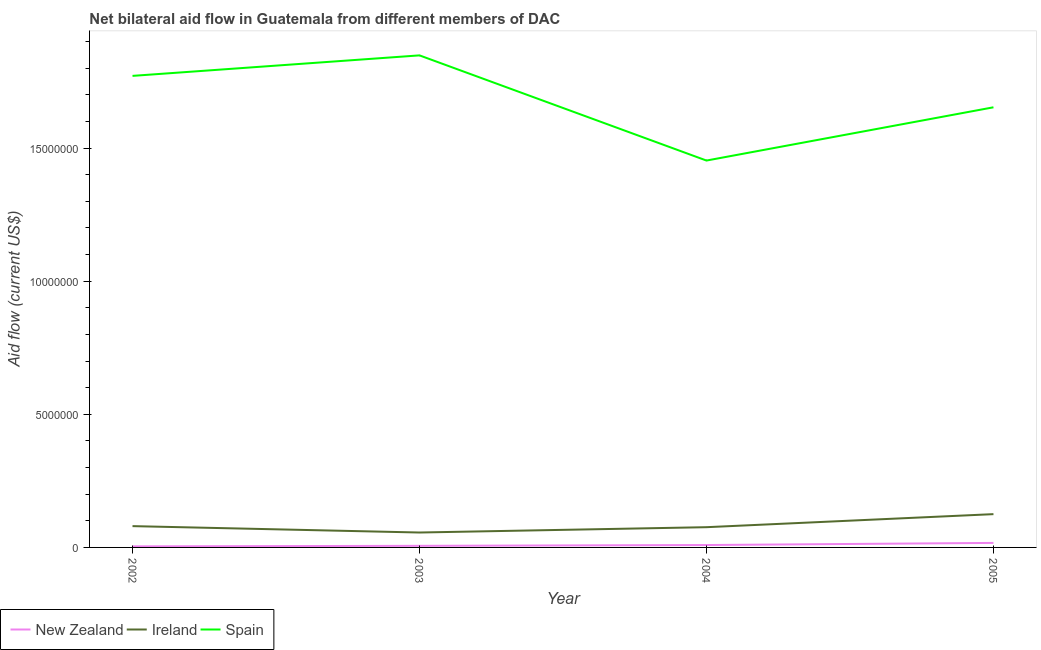What is the amount of aid provided by ireland in 2003?
Your answer should be very brief. 5.60e+05. Across all years, what is the maximum amount of aid provided by spain?
Provide a succinct answer. 1.85e+07. Across all years, what is the minimum amount of aid provided by spain?
Provide a short and direct response. 1.45e+07. In which year was the amount of aid provided by ireland minimum?
Keep it short and to the point. 2003. What is the total amount of aid provided by new zealand in the graph?
Ensure brevity in your answer.  3.60e+05. What is the difference between the amount of aid provided by ireland in 2003 and that in 2005?
Your answer should be compact. -6.90e+05. What is the difference between the amount of aid provided by spain in 2004 and the amount of aid provided by ireland in 2005?
Offer a terse response. 1.33e+07. What is the average amount of aid provided by spain per year?
Offer a very short reply. 1.68e+07. In the year 2005, what is the difference between the amount of aid provided by ireland and amount of aid provided by new zealand?
Ensure brevity in your answer.  1.08e+06. What is the ratio of the amount of aid provided by new zealand in 2003 to that in 2004?
Your answer should be very brief. 0.67. Is the amount of aid provided by ireland in 2003 less than that in 2004?
Ensure brevity in your answer.  Yes. What is the difference between the highest and the second highest amount of aid provided by spain?
Provide a short and direct response. 7.70e+05. What is the difference between the highest and the lowest amount of aid provided by spain?
Your answer should be compact. 3.95e+06. In how many years, is the amount of aid provided by new zealand greater than the average amount of aid provided by new zealand taken over all years?
Offer a terse response. 1. Is it the case that in every year, the sum of the amount of aid provided by new zealand and amount of aid provided by ireland is greater than the amount of aid provided by spain?
Provide a short and direct response. No. Is the amount of aid provided by spain strictly less than the amount of aid provided by ireland over the years?
Provide a short and direct response. No. How many lines are there?
Your response must be concise. 3. What is the difference between two consecutive major ticks on the Y-axis?
Offer a very short reply. 5.00e+06. Does the graph contain any zero values?
Make the answer very short. No. Does the graph contain grids?
Make the answer very short. No. Where does the legend appear in the graph?
Provide a succinct answer. Bottom left. How many legend labels are there?
Ensure brevity in your answer.  3. What is the title of the graph?
Make the answer very short. Net bilateral aid flow in Guatemala from different members of DAC. What is the label or title of the X-axis?
Your answer should be compact. Year. What is the Aid flow (current US$) in New Zealand in 2002?
Your response must be concise. 4.00e+04. What is the Aid flow (current US$) of Ireland in 2002?
Ensure brevity in your answer.  8.00e+05. What is the Aid flow (current US$) of Spain in 2002?
Your response must be concise. 1.77e+07. What is the Aid flow (current US$) in New Zealand in 2003?
Provide a short and direct response. 6.00e+04. What is the Aid flow (current US$) in Ireland in 2003?
Your answer should be very brief. 5.60e+05. What is the Aid flow (current US$) of Spain in 2003?
Your response must be concise. 1.85e+07. What is the Aid flow (current US$) of New Zealand in 2004?
Give a very brief answer. 9.00e+04. What is the Aid flow (current US$) of Ireland in 2004?
Make the answer very short. 7.60e+05. What is the Aid flow (current US$) of Spain in 2004?
Provide a short and direct response. 1.45e+07. What is the Aid flow (current US$) of Ireland in 2005?
Offer a terse response. 1.25e+06. What is the Aid flow (current US$) in Spain in 2005?
Offer a terse response. 1.65e+07. Across all years, what is the maximum Aid flow (current US$) in Ireland?
Your answer should be compact. 1.25e+06. Across all years, what is the maximum Aid flow (current US$) in Spain?
Your answer should be very brief. 1.85e+07. Across all years, what is the minimum Aid flow (current US$) in Ireland?
Make the answer very short. 5.60e+05. Across all years, what is the minimum Aid flow (current US$) in Spain?
Make the answer very short. 1.45e+07. What is the total Aid flow (current US$) in New Zealand in the graph?
Provide a succinct answer. 3.60e+05. What is the total Aid flow (current US$) in Ireland in the graph?
Provide a succinct answer. 3.37e+06. What is the total Aid flow (current US$) of Spain in the graph?
Give a very brief answer. 6.72e+07. What is the difference between the Aid flow (current US$) of New Zealand in 2002 and that in 2003?
Keep it short and to the point. -2.00e+04. What is the difference between the Aid flow (current US$) of Spain in 2002 and that in 2003?
Provide a succinct answer. -7.70e+05. What is the difference between the Aid flow (current US$) in Ireland in 2002 and that in 2004?
Keep it short and to the point. 4.00e+04. What is the difference between the Aid flow (current US$) of Spain in 2002 and that in 2004?
Provide a short and direct response. 3.18e+06. What is the difference between the Aid flow (current US$) of Ireland in 2002 and that in 2005?
Keep it short and to the point. -4.50e+05. What is the difference between the Aid flow (current US$) of Spain in 2002 and that in 2005?
Keep it short and to the point. 1.18e+06. What is the difference between the Aid flow (current US$) in New Zealand in 2003 and that in 2004?
Make the answer very short. -3.00e+04. What is the difference between the Aid flow (current US$) in Spain in 2003 and that in 2004?
Ensure brevity in your answer.  3.95e+06. What is the difference between the Aid flow (current US$) in New Zealand in 2003 and that in 2005?
Offer a very short reply. -1.10e+05. What is the difference between the Aid flow (current US$) in Ireland in 2003 and that in 2005?
Make the answer very short. -6.90e+05. What is the difference between the Aid flow (current US$) of Spain in 2003 and that in 2005?
Offer a very short reply. 1.95e+06. What is the difference between the Aid flow (current US$) of Ireland in 2004 and that in 2005?
Your answer should be very brief. -4.90e+05. What is the difference between the Aid flow (current US$) of Spain in 2004 and that in 2005?
Provide a succinct answer. -2.00e+06. What is the difference between the Aid flow (current US$) in New Zealand in 2002 and the Aid flow (current US$) in Ireland in 2003?
Your answer should be very brief. -5.20e+05. What is the difference between the Aid flow (current US$) in New Zealand in 2002 and the Aid flow (current US$) in Spain in 2003?
Your response must be concise. -1.84e+07. What is the difference between the Aid flow (current US$) in Ireland in 2002 and the Aid flow (current US$) in Spain in 2003?
Make the answer very short. -1.77e+07. What is the difference between the Aid flow (current US$) in New Zealand in 2002 and the Aid flow (current US$) in Ireland in 2004?
Give a very brief answer. -7.20e+05. What is the difference between the Aid flow (current US$) of New Zealand in 2002 and the Aid flow (current US$) of Spain in 2004?
Keep it short and to the point. -1.45e+07. What is the difference between the Aid flow (current US$) of Ireland in 2002 and the Aid flow (current US$) of Spain in 2004?
Your answer should be compact. -1.37e+07. What is the difference between the Aid flow (current US$) in New Zealand in 2002 and the Aid flow (current US$) in Ireland in 2005?
Offer a terse response. -1.21e+06. What is the difference between the Aid flow (current US$) in New Zealand in 2002 and the Aid flow (current US$) in Spain in 2005?
Offer a terse response. -1.65e+07. What is the difference between the Aid flow (current US$) of Ireland in 2002 and the Aid flow (current US$) of Spain in 2005?
Give a very brief answer. -1.57e+07. What is the difference between the Aid flow (current US$) of New Zealand in 2003 and the Aid flow (current US$) of Ireland in 2004?
Provide a short and direct response. -7.00e+05. What is the difference between the Aid flow (current US$) in New Zealand in 2003 and the Aid flow (current US$) in Spain in 2004?
Offer a terse response. -1.45e+07. What is the difference between the Aid flow (current US$) of Ireland in 2003 and the Aid flow (current US$) of Spain in 2004?
Offer a very short reply. -1.40e+07. What is the difference between the Aid flow (current US$) of New Zealand in 2003 and the Aid flow (current US$) of Ireland in 2005?
Provide a succinct answer. -1.19e+06. What is the difference between the Aid flow (current US$) in New Zealand in 2003 and the Aid flow (current US$) in Spain in 2005?
Provide a succinct answer. -1.65e+07. What is the difference between the Aid flow (current US$) of Ireland in 2003 and the Aid flow (current US$) of Spain in 2005?
Make the answer very short. -1.60e+07. What is the difference between the Aid flow (current US$) of New Zealand in 2004 and the Aid flow (current US$) of Ireland in 2005?
Ensure brevity in your answer.  -1.16e+06. What is the difference between the Aid flow (current US$) of New Zealand in 2004 and the Aid flow (current US$) of Spain in 2005?
Make the answer very short. -1.64e+07. What is the difference between the Aid flow (current US$) in Ireland in 2004 and the Aid flow (current US$) in Spain in 2005?
Make the answer very short. -1.58e+07. What is the average Aid flow (current US$) in Ireland per year?
Provide a succinct answer. 8.42e+05. What is the average Aid flow (current US$) in Spain per year?
Provide a short and direct response. 1.68e+07. In the year 2002, what is the difference between the Aid flow (current US$) in New Zealand and Aid flow (current US$) in Ireland?
Provide a succinct answer. -7.60e+05. In the year 2002, what is the difference between the Aid flow (current US$) in New Zealand and Aid flow (current US$) in Spain?
Provide a short and direct response. -1.77e+07. In the year 2002, what is the difference between the Aid flow (current US$) in Ireland and Aid flow (current US$) in Spain?
Ensure brevity in your answer.  -1.69e+07. In the year 2003, what is the difference between the Aid flow (current US$) in New Zealand and Aid flow (current US$) in Ireland?
Offer a very short reply. -5.00e+05. In the year 2003, what is the difference between the Aid flow (current US$) of New Zealand and Aid flow (current US$) of Spain?
Make the answer very short. -1.84e+07. In the year 2003, what is the difference between the Aid flow (current US$) of Ireland and Aid flow (current US$) of Spain?
Provide a short and direct response. -1.79e+07. In the year 2004, what is the difference between the Aid flow (current US$) of New Zealand and Aid flow (current US$) of Ireland?
Offer a very short reply. -6.70e+05. In the year 2004, what is the difference between the Aid flow (current US$) of New Zealand and Aid flow (current US$) of Spain?
Offer a very short reply. -1.44e+07. In the year 2004, what is the difference between the Aid flow (current US$) in Ireland and Aid flow (current US$) in Spain?
Your answer should be compact. -1.38e+07. In the year 2005, what is the difference between the Aid flow (current US$) of New Zealand and Aid flow (current US$) of Ireland?
Your response must be concise. -1.08e+06. In the year 2005, what is the difference between the Aid flow (current US$) of New Zealand and Aid flow (current US$) of Spain?
Provide a succinct answer. -1.64e+07. In the year 2005, what is the difference between the Aid flow (current US$) in Ireland and Aid flow (current US$) in Spain?
Provide a succinct answer. -1.53e+07. What is the ratio of the Aid flow (current US$) of Ireland in 2002 to that in 2003?
Offer a very short reply. 1.43. What is the ratio of the Aid flow (current US$) in Spain in 2002 to that in 2003?
Offer a very short reply. 0.96. What is the ratio of the Aid flow (current US$) of New Zealand in 2002 to that in 2004?
Give a very brief answer. 0.44. What is the ratio of the Aid flow (current US$) in Ireland in 2002 to that in 2004?
Provide a succinct answer. 1.05. What is the ratio of the Aid flow (current US$) in Spain in 2002 to that in 2004?
Your answer should be compact. 1.22. What is the ratio of the Aid flow (current US$) of New Zealand in 2002 to that in 2005?
Provide a short and direct response. 0.24. What is the ratio of the Aid flow (current US$) of Ireland in 2002 to that in 2005?
Provide a short and direct response. 0.64. What is the ratio of the Aid flow (current US$) of Spain in 2002 to that in 2005?
Your answer should be compact. 1.07. What is the ratio of the Aid flow (current US$) in Ireland in 2003 to that in 2004?
Keep it short and to the point. 0.74. What is the ratio of the Aid flow (current US$) of Spain in 2003 to that in 2004?
Your answer should be very brief. 1.27. What is the ratio of the Aid flow (current US$) in New Zealand in 2003 to that in 2005?
Ensure brevity in your answer.  0.35. What is the ratio of the Aid flow (current US$) in Ireland in 2003 to that in 2005?
Your answer should be very brief. 0.45. What is the ratio of the Aid flow (current US$) in Spain in 2003 to that in 2005?
Your answer should be compact. 1.12. What is the ratio of the Aid flow (current US$) in New Zealand in 2004 to that in 2005?
Provide a short and direct response. 0.53. What is the ratio of the Aid flow (current US$) in Ireland in 2004 to that in 2005?
Give a very brief answer. 0.61. What is the ratio of the Aid flow (current US$) in Spain in 2004 to that in 2005?
Keep it short and to the point. 0.88. What is the difference between the highest and the second highest Aid flow (current US$) in Ireland?
Make the answer very short. 4.50e+05. What is the difference between the highest and the second highest Aid flow (current US$) of Spain?
Give a very brief answer. 7.70e+05. What is the difference between the highest and the lowest Aid flow (current US$) in Ireland?
Your response must be concise. 6.90e+05. What is the difference between the highest and the lowest Aid flow (current US$) of Spain?
Ensure brevity in your answer.  3.95e+06. 